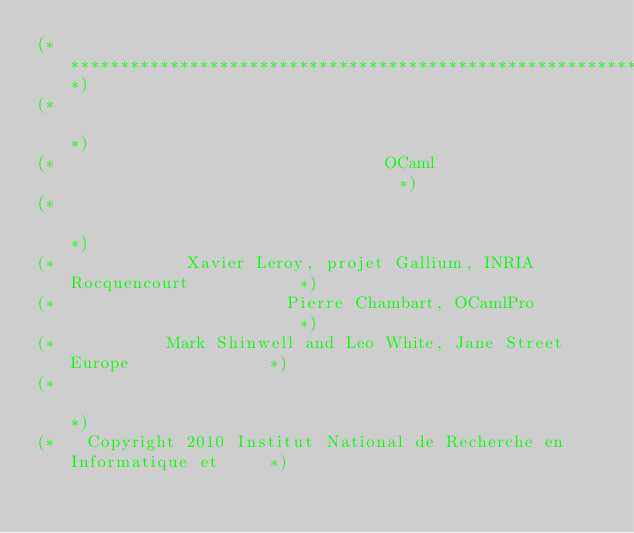<code> <loc_0><loc_0><loc_500><loc_500><_OCaml_>(**************************************************************************)
(*                                                                        *)
(*                                 OCaml                                  *)
(*                                                                        *)
(*             Xavier Leroy, projet Gallium, INRIA Rocquencourt           *)
(*                       Pierre Chambart, OCamlPro                        *)
(*           Mark Shinwell and Leo White, Jane Street Europe              *)
(*                                                                        *)
(*   Copyright 2010 Institut National de Recherche en Informatique et     *)</code> 